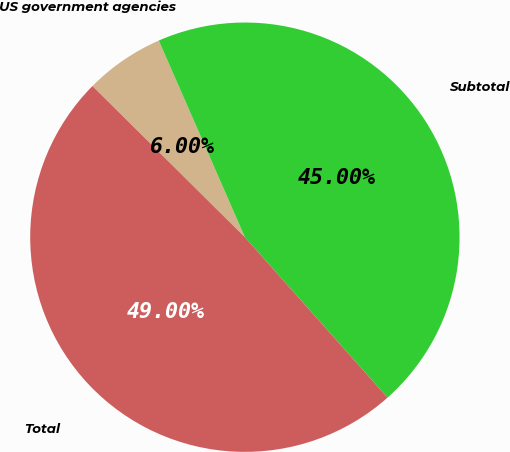<chart> <loc_0><loc_0><loc_500><loc_500><pie_chart><fcel>US government agencies<fcel>Subtotal<fcel>Total<nl><fcel>6.0%<fcel>45.0%<fcel>49.0%<nl></chart> 